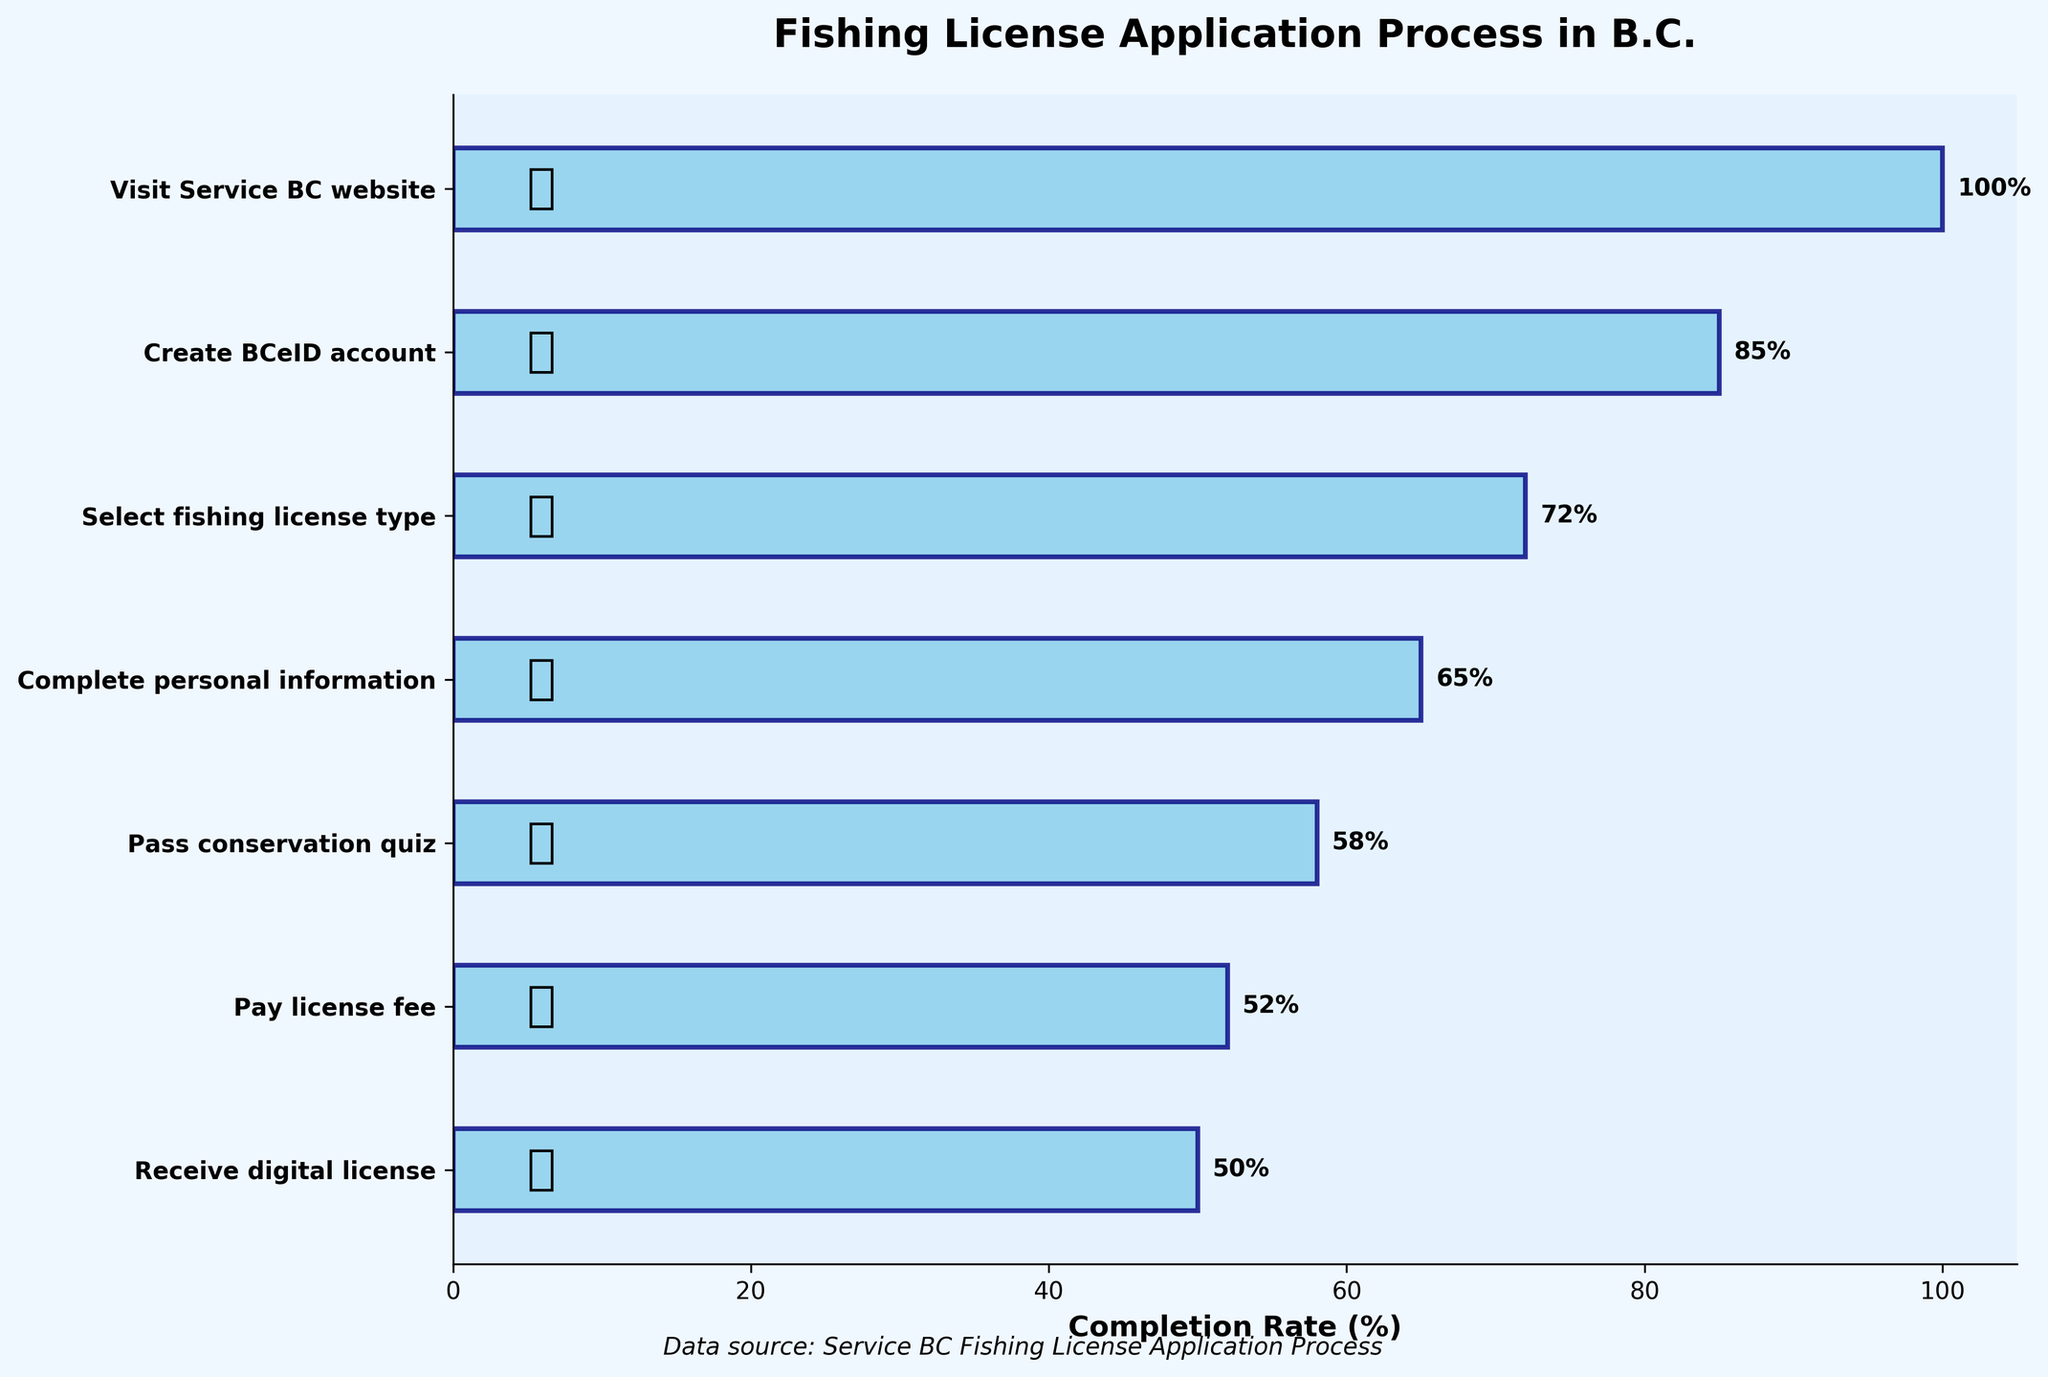What's the title of the figure? The title is usually found at the top of the chart. In this case, it's displayed prominently to describe what the chart is about.
Answer: Fishing License Application Process in B.C How many steps are there in the fishing license application process? By counting the distinct steps displayed on the y-axis of the chart, we can determine the number of steps involved.
Answer: 7 Which step has the highest completion rate? The step with the highest completion rate will be the one with the longest bar. From the figure, the longest bar corresponds to "Visit Service BC website."
Answer: Visit Service BC website Which step shows the largest drop in completion rate compared to the previous step? To find this, subtract the completion rates of consecutive steps and identify the largest difference. From the data, "Pass conservation quiz" has a drop from 65% to 58%, which is the largest drop of 7%.
Answer: Pass conservation quiz What's the difference in completion rates between "Create BCeID account" and "Receive digital license"? By identifying the completion rates of each step and subtracting them, we find the difference. 85% (Create BCeID account) - 50% (Receive digital license) = 35%.
Answer: 35% What is the average completion rate of all the steps? Sum the completion rates and divide by the number of steps. (100 + 85 + 72 + 65 + 58 + 52 + 50) / 7 = 68%
Answer: 68% Which step has the lowest completion rate? The step with the shortest bar has the lowest completion rate. In the figure, this is "Receive digital license."
Answer: Receive digital license Between which two consecutive steps is the completion rate closest? By calculating the differences between all consecutive steps and finding the smallest difference, the closest rates are between "Pay license fee" (52%) and "Receive digital license" (50%), with a difference of 2%.
Answer: Pay license fee and Receive digital license What is the total drop in completion rate from the first step to the last step? Subtract the completion rate of the first step (100%) from the rate of the last step (50%). 100% - 50% = 50%
Answer: 50% What percentage of people complete the personal information step and go on to pay the license fee? The completion rates for these steps are 65% and 52%, respectively. To find the percentage going from one step to the next, (52/65) * 100 = 80%.
Answer: 80% 